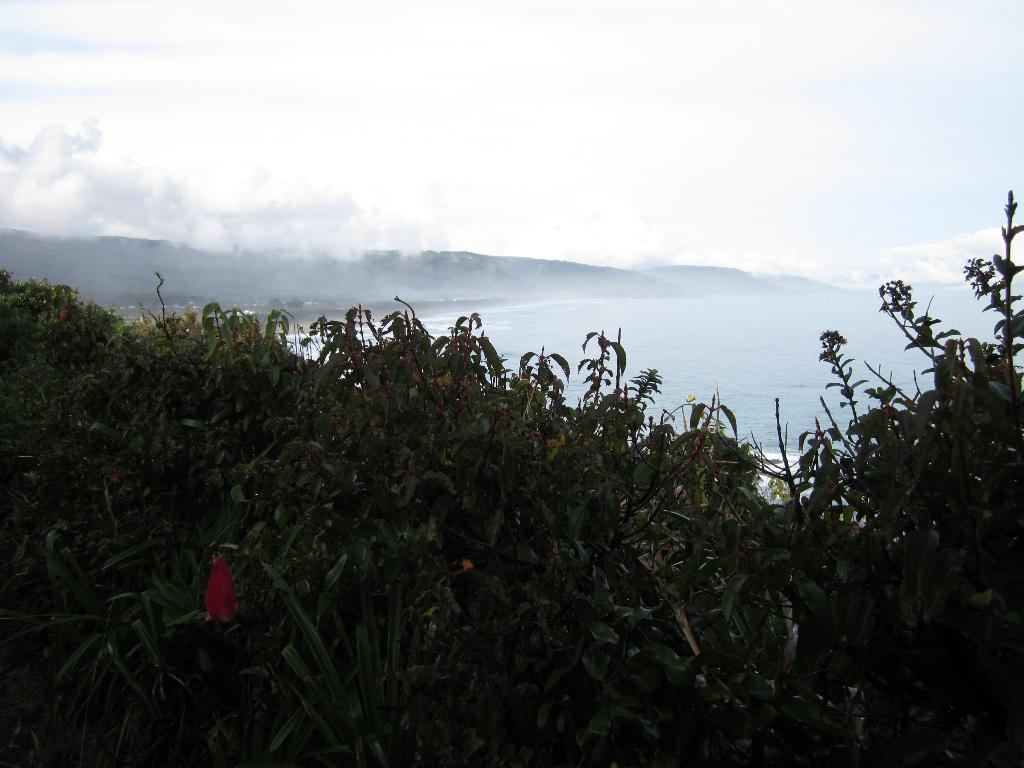What type of living organisms can be seen in the image? Plants can be seen in the image. What is visible in the image besides the plants? Water, hills, and clouds are visible in the image. What is the name of the plant that produces berries in the image? There is no specific plant mentioned in the image, nor is there any indication of berries being present. 